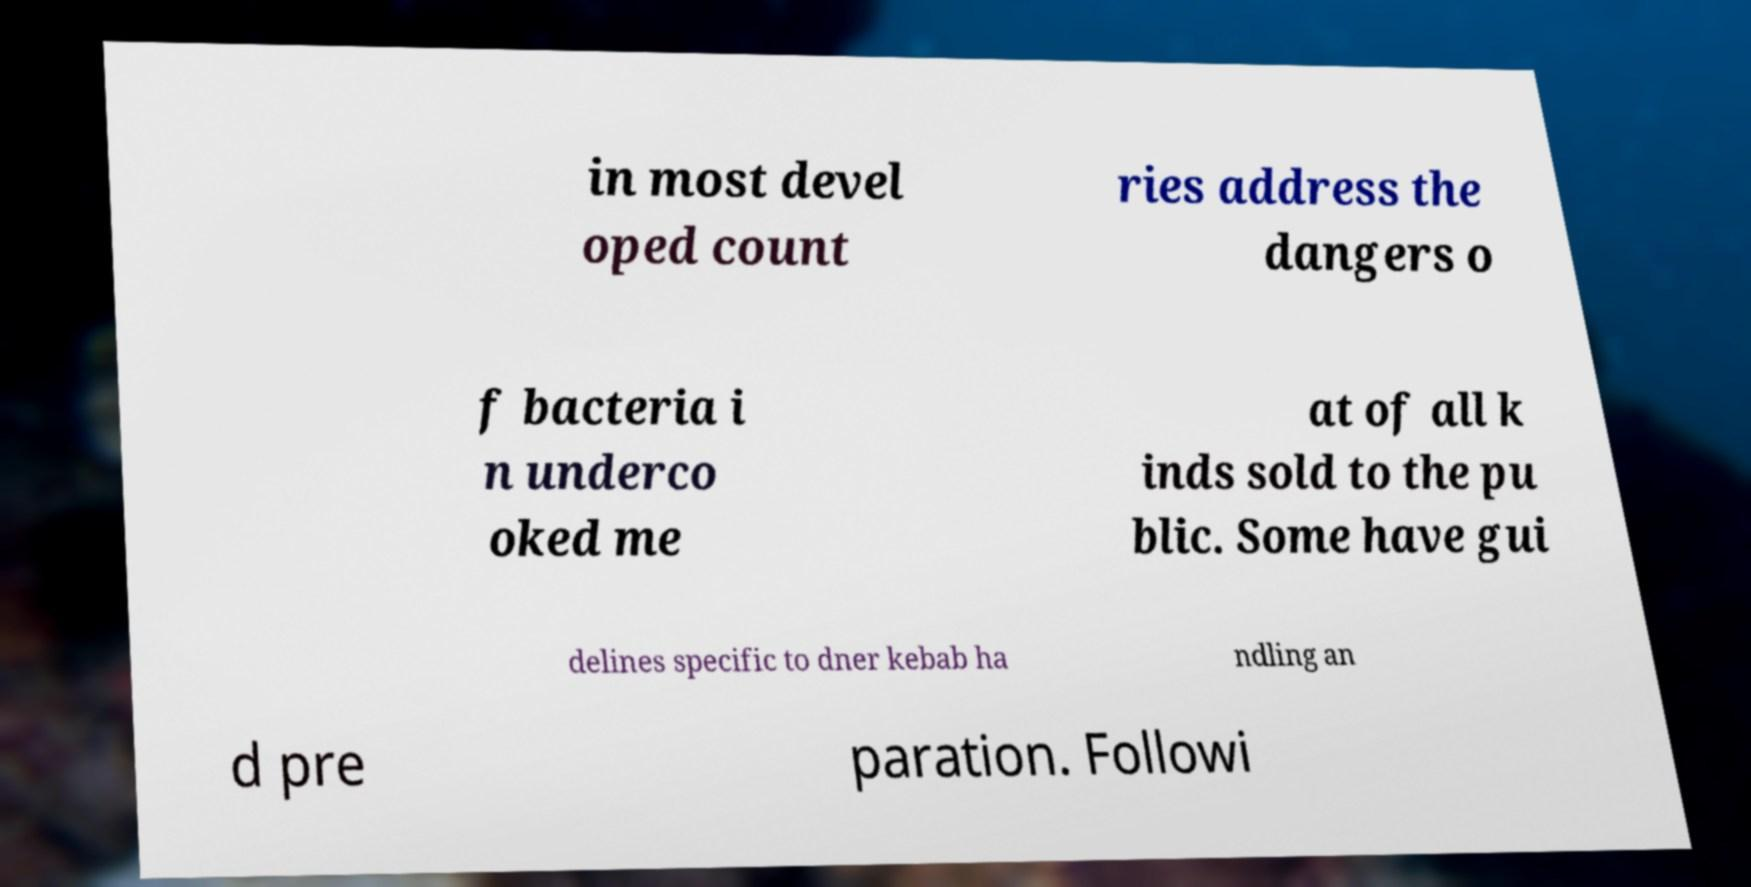I need the written content from this picture converted into text. Can you do that? in most devel oped count ries address the dangers o f bacteria i n underco oked me at of all k inds sold to the pu blic. Some have gui delines specific to dner kebab ha ndling an d pre paration. Followi 